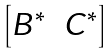<formula> <loc_0><loc_0><loc_500><loc_500>\begin{bmatrix} B ^ { * } & C ^ { * } \end{bmatrix}</formula> 